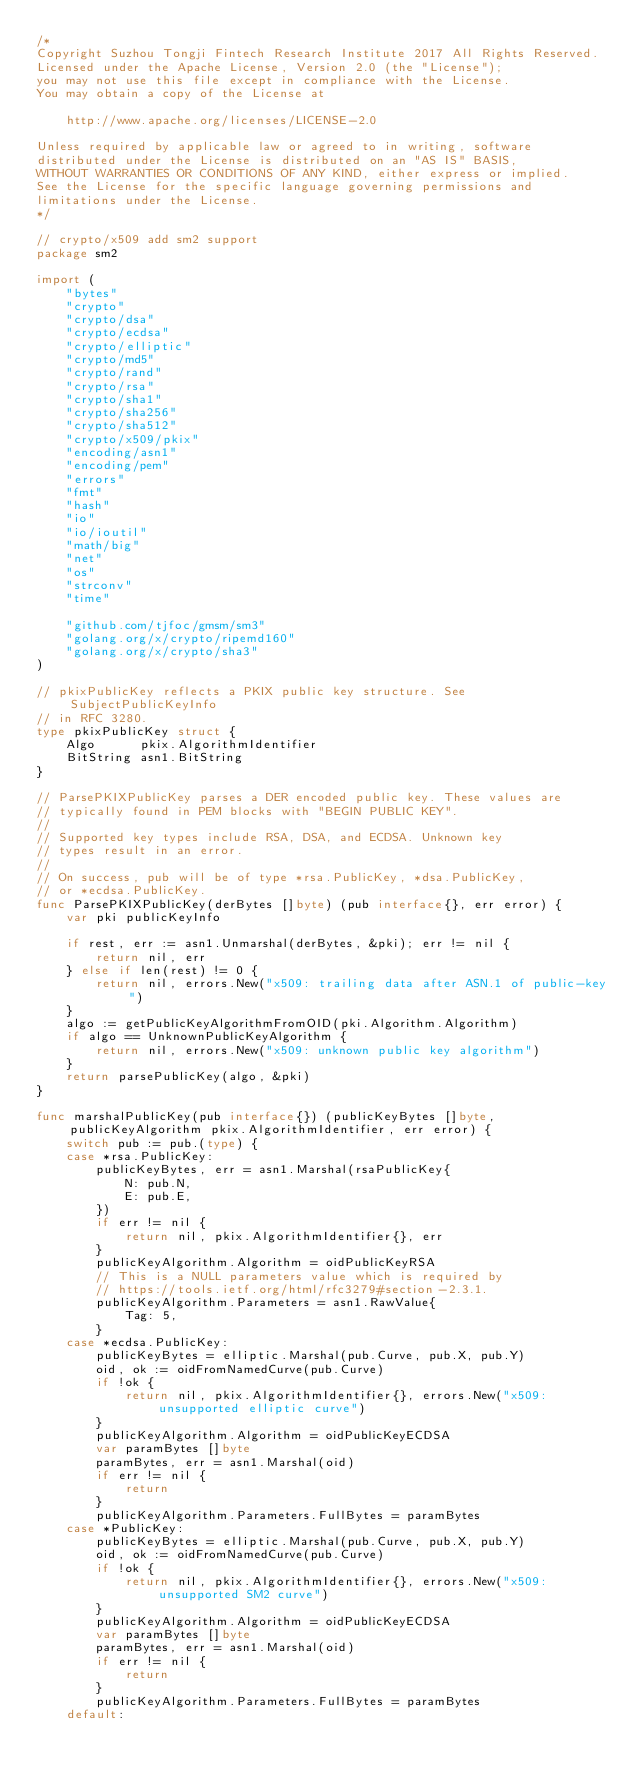Convert code to text. <code><loc_0><loc_0><loc_500><loc_500><_Go_>/*
Copyright Suzhou Tongji Fintech Research Institute 2017 All Rights Reserved.
Licensed under the Apache License, Version 2.0 (the "License");
you may not use this file except in compliance with the License.
You may obtain a copy of the License at

	http://www.apache.org/licenses/LICENSE-2.0

Unless required by applicable law or agreed to in writing, software
distributed under the License is distributed on an "AS IS" BASIS,
WITHOUT WARRANTIES OR CONDITIONS OF ANY KIND, either express or implied.
See the License for the specific language governing permissions and
limitations under the License.
*/

// crypto/x509 add sm2 support
package sm2

import (
	"bytes"
	"crypto"
	"crypto/dsa"
	"crypto/ecdsa"
	"crypto/elliptic"
	"crypto/md5"
	"crypto/rand"
	"crypto/rsa"
	"crypto/sha1"
	"crypto/sha256"
	"crypto/sha512"
	"crypto/x509/pkix"
	"encoding/asn1"
	"encoding/pem"
	"errors"
	"fmt"
	"hash"
	"io"
	"io/ioutil"
	"math/big"
	"net"
	"os"
	"strconv"
	"time"

	"github.com/tjfoc/gmsm/sm3"
	"golang.org/x/crypto/ripemd160"
	"golang.org/x/crypto/sha3"
)

// pkixPublicKey reflects a PKIX public key structure. See SubjectPublicKeyInfo
// in RFC 3280.
type pkixPublicKey struct {
	Algo      pkix.AlgorithmIdentifier
	BitString asn1.BitString
}

// ParsePKIXPublicKey parses a DER encoded public key. These values are
// typically found in PEM blocks with "BEGIN PUBLIC KEY".
//
// Supported key types include RSA, DSA, and ECDSA. Unknown key
// types result in an error.
//
// On success, pub will be of type *rsa.PublicKey, *dsa.PublicKey,
// or *ecdsa.PublicKey.
func ParsePKIXPublicKey(derBytes []byte) (pub interface{}, err error) {
	var pki publicKeyInfo

	if rest, err := asn1.Unmarshal(derBytes, &pki); err != nil {
		return nil, err
	} else if len(rest) != 0 {
		return nil, errors.New("x509: trailing data after ASN.1 of public-key")
	}
	algo := getPublicKeyAlgorithmFromOID(pki.Algorithm.Algorithm)
	if algo == UnknownPublicKeyAlgorithm {
		return nil, errors.New("x509: unknown public key algorithm")
	}
	return parsePublicKey(algo, &pki)
}

func marshalPublicKey(pub interface{}) (publicKeyBytes []byte, publicKeyAlgorithm pkix.AlgorithmIdentifier, err error) {
	switch pub := pub.(type) {
	case *rsa.PublicKey:
		publicKeyBytes, err = asn1.Marshal(rsaPublicKey{
			N: pub.N,
			E: pub.E,
		})
		if err != nil {
			return nil, pkix.AlgorithmIdentifier{}, err
		}
		publicKeyAlgorithm.Algorithm = oidPublicKeyRSA
		// This is a NULL parameters value which is required by
		// https://tools.ietf.org/html/rfc3279#section-2.3.1.
		publicKeyAlgorithm.Parameters = asn1.RawValue{
			Tag: 5,
		}
	case *ecdsa.PublicKey:
		publicKeyBytes = elliptic.Marshal(pub.Curve, pub.X, pub.Y)
		oid, ok := oidFromNamedCurve(pub.Curve)
		if !ok {
			return nil, pkix.AlgorithmIdentifier{}, errors.New("x509: unsupported elliptic curve")
		}
		publicKeyAlgorithm.Algorithm = oidPublicKeyECDSA
		var paramBytes []byte
		paramBytes, err = asn1.Marshal(oid)
		if err != nil {
			return
		}
		publicKeyAlgorithm.Parameters.FullBytes = paramBytes
	case *PublicKey:
		publicKeyBytes = elliptic.Marshal(pub.Curve, pub.X, pub.Y)
		oid, ok := oidFromNamedCurve(pub.Curve)
		if !ok {
			return nil, pkix.AlgorithmIdentifier{}, errors.New("x509: unsupported SM2 curve")
		}
		publicKeyAlgorithm.Algorithm = oidPublicKeyECDSA
		var paramBytes []byte
		paramBytes, err = asn1.Marshal(oid)
		if err != nil {
			return
		}
		publicKeyAlgorithm.Parameters.FullBytes = paramBytes
	default:</code> 